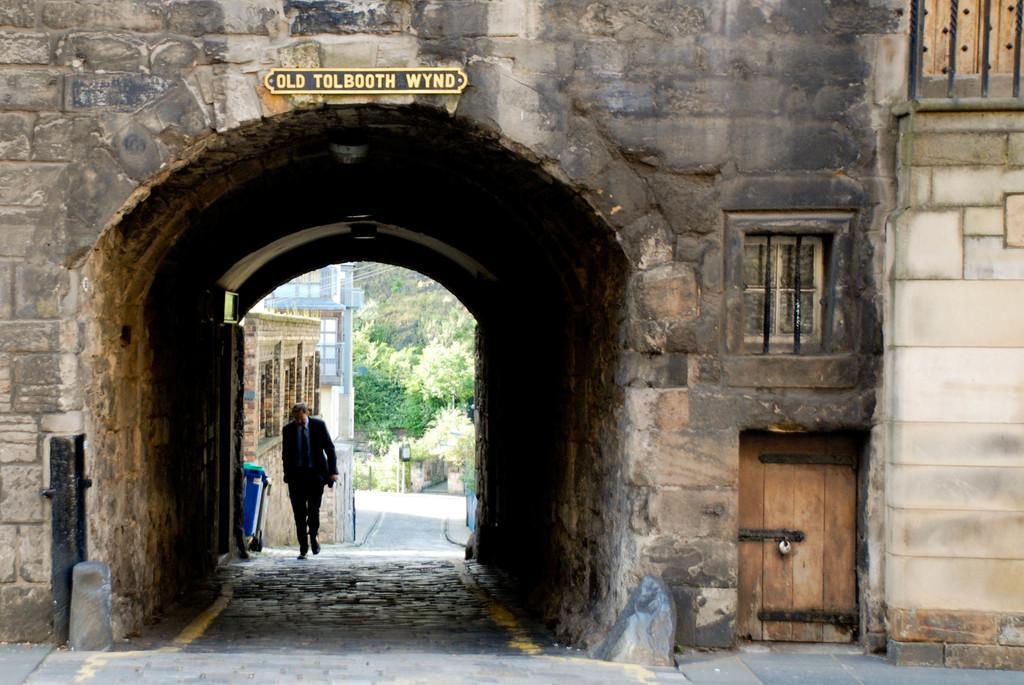Describe this image in one or two sentences. In this image we can see a tunnel which is of stone a person wearing suit walking through the tunnel and in the background of the image there are some trees, houses. There is door and window to the tunnel. 